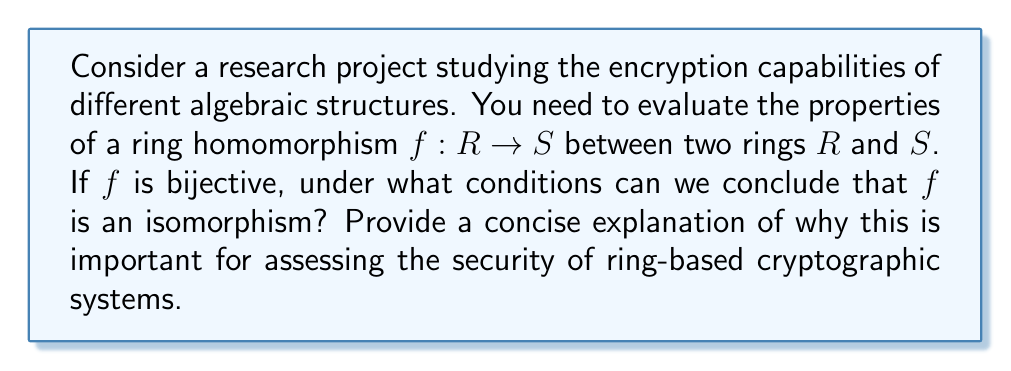Help me with this question. To address this question, we need to understand the relationship between ring homomorphisms and isomorphisms:

1. Ring Homomorphism:
   A function $f: R \rightarrow S$ is a ring homomorphism if for all $a, b \in R$:
   
   a) $f(a + b) = f(a) + f(b)$
   b) $f(ab) = f(a)f(b)$
   c) $f(1_R) = 1_S$ (where $1_R$ and $1_S$ are the multiplicative identities in $R$ and $S$ respectively)

2. Ring Isomorphism:
   A ring isomorphism is a bijective ring homomorphism.

3. Conditions for Isomorphism:
   For a bijective ring homomorphism $f: R \rightarrow S$ to be an isomorphism, we need to ensure that its inverse function $f^{-1}: S \rightarrow R$ is also a ring homomorphism.

4. Proof:
   - We already know $f$ is bijective and a ring homomorphism.
   - We need to show that $f^{-1}$ preserves addition and multiplication.
   
   For addition:
   Let $x, y \in S$. Then there exist unique $a, b \in R$ such that $f(a) = x$ and $f(b) = y$.
   $$f^{-1}(x + y) = f^{-1}(f(a) + f(b)) = f^{-1}(f(a + b)) = a + b = f^{-1}(x) + f^{-1}(y)$$
   
   For multiplication:
   $$f^{-1}(xy) = f^{-1}(f(a)f(b)) = f^{-1}(f(ab)) = ab = f^{-1}(x)f^{-1}(y)$$

   Therefore, $f^{-1}$ is also a ring homomorphism, and $f$ is an isomorphism.

5. Importance in Cryptography:
   In ring-based cryptographic systems, the security often relies on the difficulty of solving certain problems in ring structures. Isomorphisms between rings can potentially reveal vulnerabilities or strengths in these systems. Understanding when a homomorphism becomes an isomorphism is crucial for:
   
   a) Assessing the equivalence of different ring representations
   b) Analyzing potential weaknesses in encryption schemes
   c) Developing new cryptographic protocols with desired algebraic properties

By knowing that a bijective ring homomorphism is always an isomorphism, cryptographers can more accurately evaluate the structural relationships between different rings used in encryption algorithms, ensuring the robustness of the cryptographic systems.
Answer: A bijective ring homomorphism $f: R \rightarrow S$ is always an isomorphism. This is because the inverse function $f^{-1}: S \rightarrow R$ is automatically a ring homomorphism when $f$ is bijective and a ring homomorphism. This property is crucial for assessing the structural equivalence of rings in cryptographic systems, which impacts the security and efficiency of ring-based encryption algorithms. 